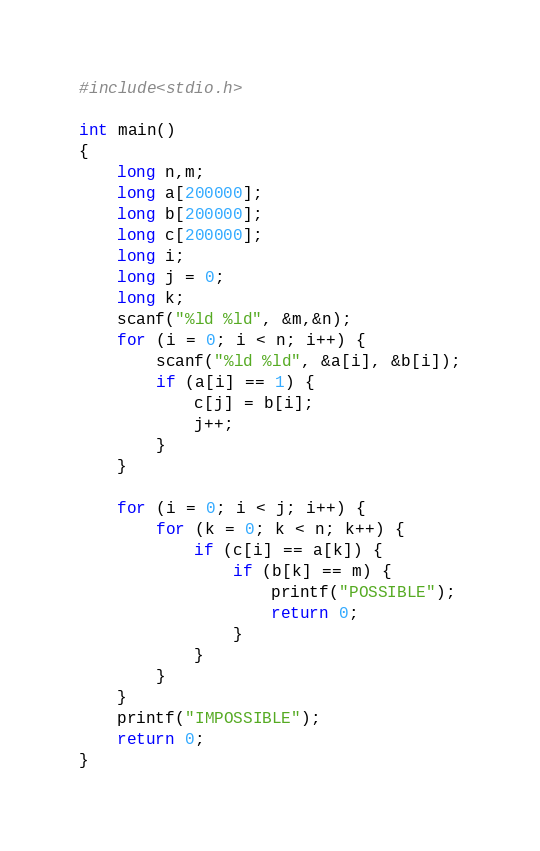Convert code to text. <code><loc_0><loc_0><loc_500><loc_500><_C_>#include<stdio.h>

int main()
{
	long n,m;
	long a[200000];
	long b[200000];
	long c[200000];
	long i;
	long j = 0;
	long k;
	scanf("%ld %ld", &m,&n);
	for (i = 0; i < n; i++) {
		scanf("%ld %ld", &a[i], &b[i]);
		if (a[i] == 1) {
			c[j] = b[i];
			j++;			
		}
	}

	for (i = 0; i < j; i++) {
		for (k = 0; k < n; k++) {
			if (c[i] == a[k]) {
				if (b[k] == m) {
					printf("POSSIBLE");
					return 0;
				}
			}
		}
	}
	printf("IMPOSSIBLE");
	return 0;
}</code> 